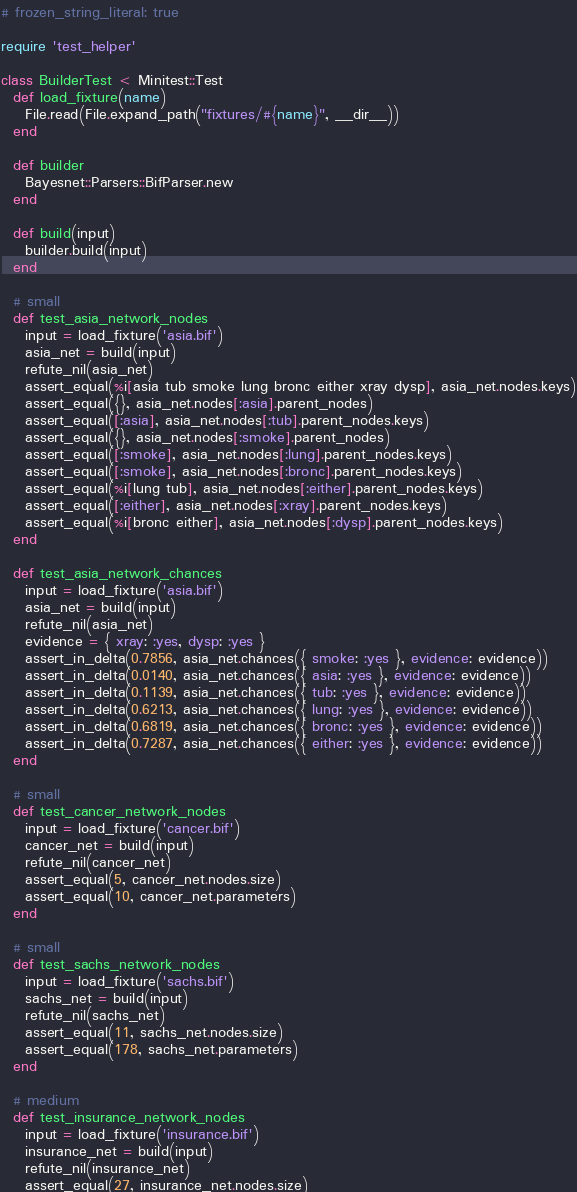Convert code to text. <code><loc_0><loc_0><loc_500><loc_500><_Ruby_># frozen_string_literal: true

require 'test_helper'

class BuilderTest < Minitest::Test
  def load_fixture(name)
    File.read(File.expand_path("fixtures/#{name}", __dir__))
  end

  def builder
    Bayesnet::Parsers::BifParser.new
  end

  def build(input)
    builder.build(input)
  end

  # small
  def test_asia_network_nodes
    input = load_fixture('asia.bif')
    asia_net = build(input)
    refute_nil(asia_net)
    assert_equal(%i[asia tub smoke lung bronc either xray dysp], asia_net.nodes.keys)
    assert_equal({}, asia_net.nodes[:asia].parent_nodes)
    assert_equal([:asia], asia_net.nodes[:tub].parent_nodes.keys)
    assert_equal({}, asia_net.nodes[:smoke].parent_nodes)
    assert_equal([:smoke], asia_net.nodes[:lung].parent_nodes.keys)
    assert_equal([:smoke], asia_net.nodes[:bronc].parent_nodes.keys)
    assert_equal(%i[lung tub], asia_net.nodes[:either].parent_nodes.keys)
    assert_equal([:either], asia_net.nodes[:xray].parent_nodes.keys)
    assert_equal(%i[bronc either], asia_net.nodes[:dysp].parent_nodes.keys)
  end

  def test_asia_network_chances
    input = load_fixture('asia.bif')
    asia_net = build(input)
    refute_nil(asia_net)
    evidence = { xray: :yes, dysp: :yes }
    assert_in_delta(0.7856, asia_net.chances({ smoke: :yes }, evidence: evidence))
    assert_in_delta(0.0140, asia_net.chances({ asia: :yes }, evidence: evidence))
    assert_in_delta(0.1139, asia_net.chances({ tub: :yes }, evidence: evidence))
    assert_in_delta(0.6213, asia_net.chances({ lung: :yes }, evidence: evidence))
    assert_in_delta(0.6819, asia_net.chances({ bronc: :yes }, evidence: evidence))
    assert_in_delta(0.7287, asia_net.chances({ either: :yes }, evidence: evidence))
  end

  # small
  def test_cancer_network_nodes
    input = load_fixture('cancer.bif')
    cancer_net = build(input)
    refute_nil(cancer_net)
    assert_equal(5, cancer_net.nodes.size)
    assert_equal(10, cancer_net.parameters)
  end

  # small
  def test_sachs_network_nodes
    input = load_fixture('sachs.bif')
    sachs_net = build(input)
    refute_nil(sachs_net)
    assert_equal(11, sachs_net.nodes.size)
    assert_equal(178, sachs_net.parameters)
  end

  # medium
  def test_insurance_network_nodes
    input = load_fixture('insurance.bif')
    insurance_net = build(input)
    refute_nil(insurance_net)
    assert_equal(27, insurance_net.nodes.size)</code> 